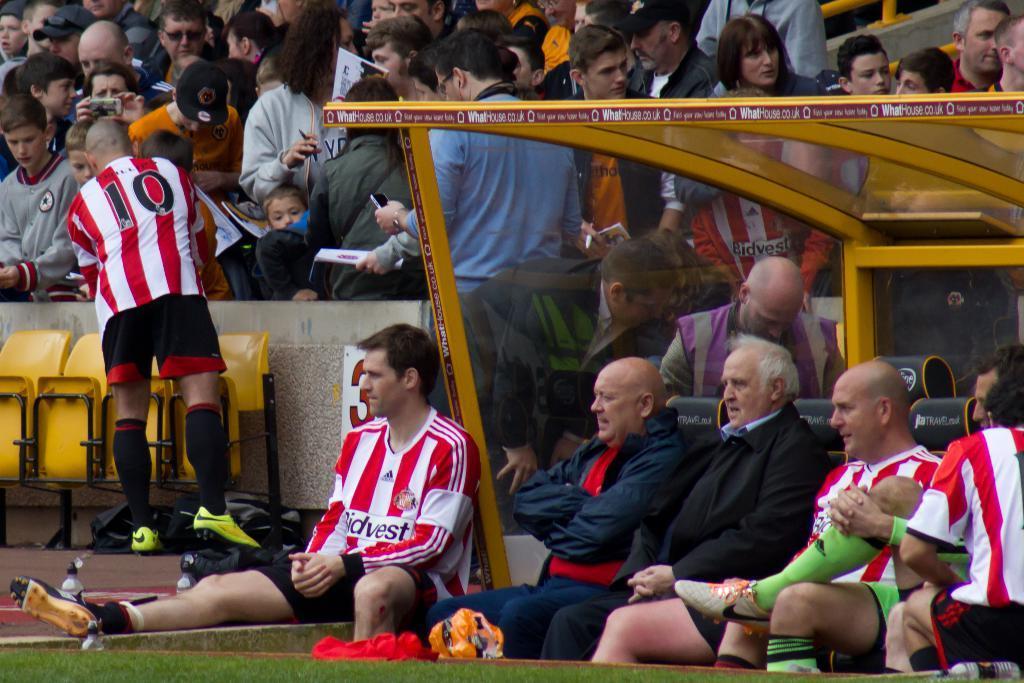Describe this image in one or two sentences. At the bottom of the image we can see many persons sitting on the chairs. In the background we can see chairs and crowd. 